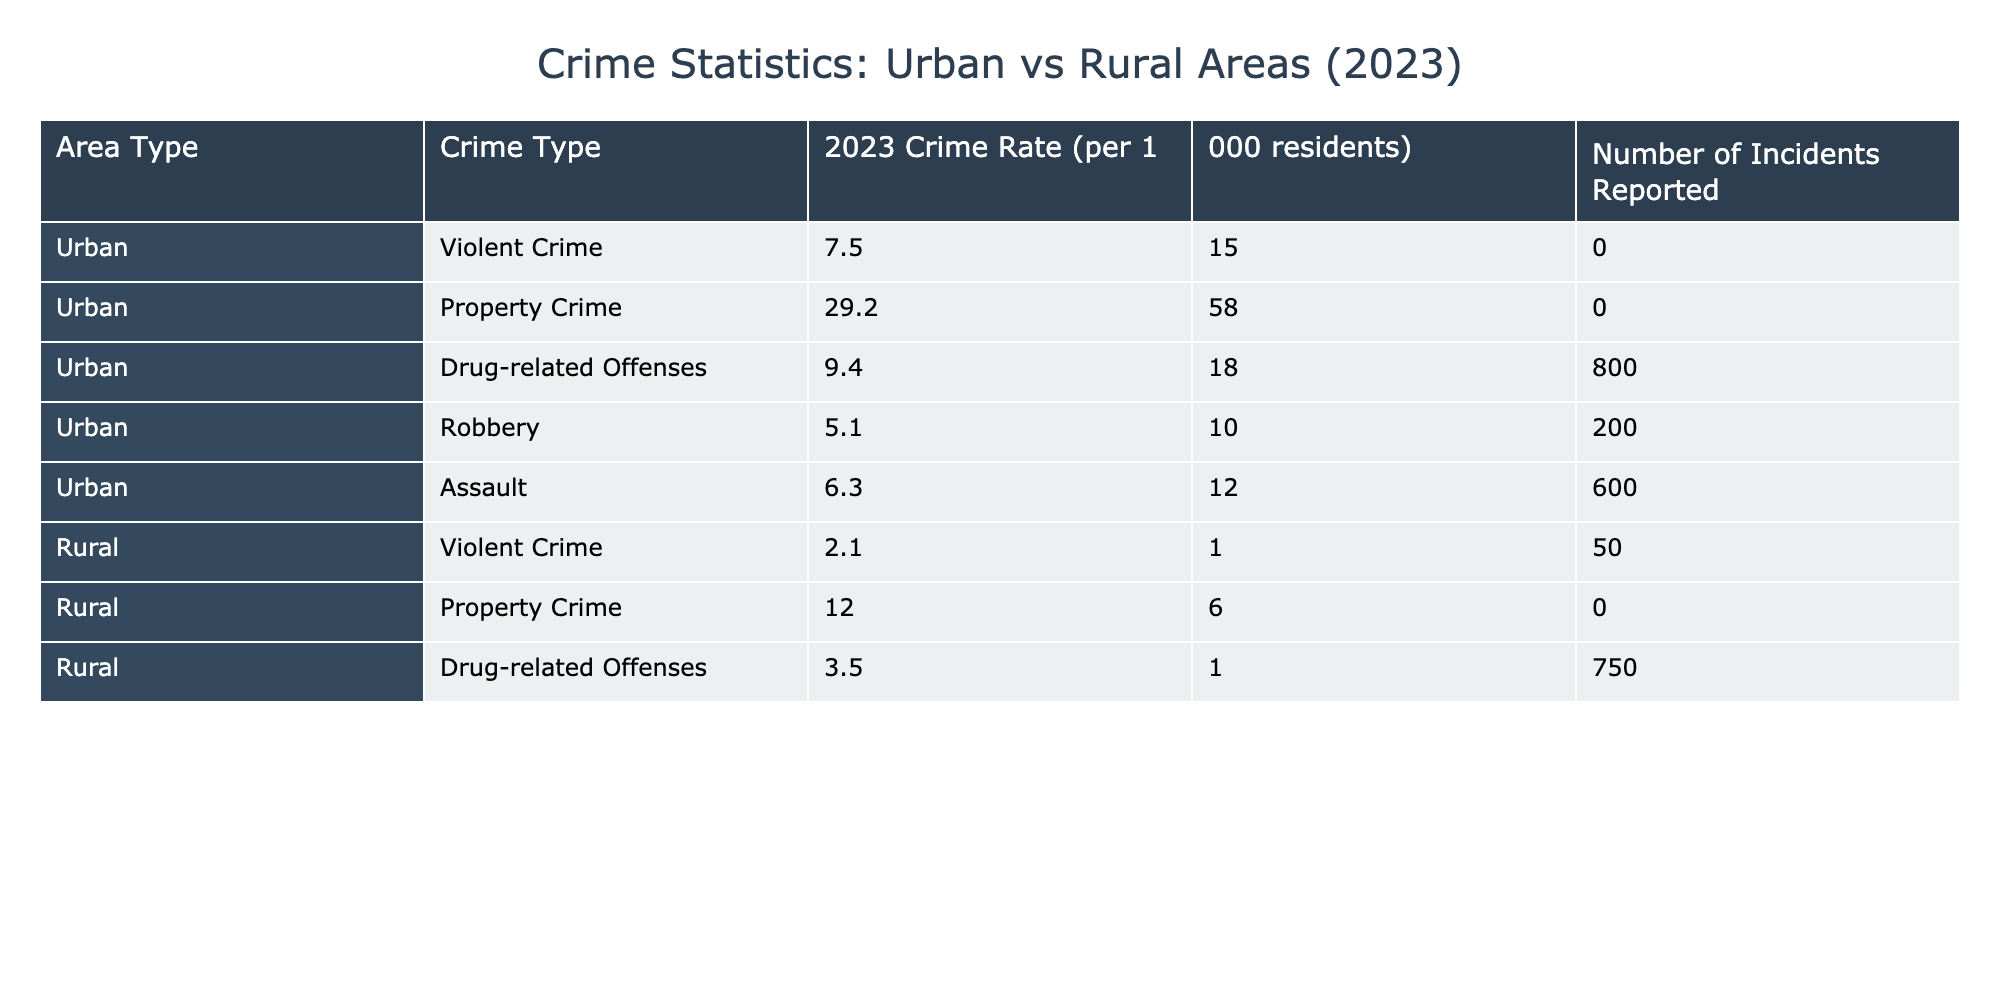What is the crime rate for violent crime in urban areas? According to the table, the crime rate for violent crime in urban areas is listed directly as 7.5 per 1,000 residents.
Answer: 7.5 What is the total number of property crime incidents reported in rural areas? The table shows that the number of incidents reported for property crime in rural areas is 6,000.
Answer: 6,000 Is the drug-related offense rate higher in urban or rural areas? The table indicates the drug-related offense rate is 9.4 in urban areas and 3.5 in rural areas. Since 9.4 is greater than 3.5, the rate is higher in urban areas.
Answer: Yes What is the difference in the crime rate for property crime between urban and rural areas? In urban areas, the property crime rate is 29.2 and in rural areas, it is 12.0. The difference is calculated as 29.2 - 12.0 = 17.2 per 1,000 residents.
Answer: 17.2 What is the average crime rate for all types of crime reported in urban areas? The crime rates in urban areas are: 7.5 (violent), 29.2 (property), 9.4 (drug-related), 5.1 (robbery), and 6.3 (assault). Summing these gives 7.5 + 29.2 + 9.4 + 5.1 + 6.3 = 57.5. There are 5 types of crime, so the average is 57.5 / 5 = 11.5 per 1,000 residents.
Answer: 11.5 Which crime type has the highest rate in urban areas? Looking at the rates for urban areas, the highest rate is for property crime at 29.2 per 1,000 residents.
Answer: Property crime How many more incidents of violent crime were reported in urban areas compared to rural areas? The number of reported violent crime incidents in urban areas is 15,000, while in rural areas, it is 1,050. The difference can be calculated as 15,000 - 1,050 = 13,950 incidents.
Answer: 13,950 Is the total number of drug-related offenses reported greater in urban or rural areas? The table shows 18,800 incidents in urban areas compared to 1,750 in rural areas. Since 18,800 is much greater than 1,750, the total is greater in urban areas.
Answer: Yes 